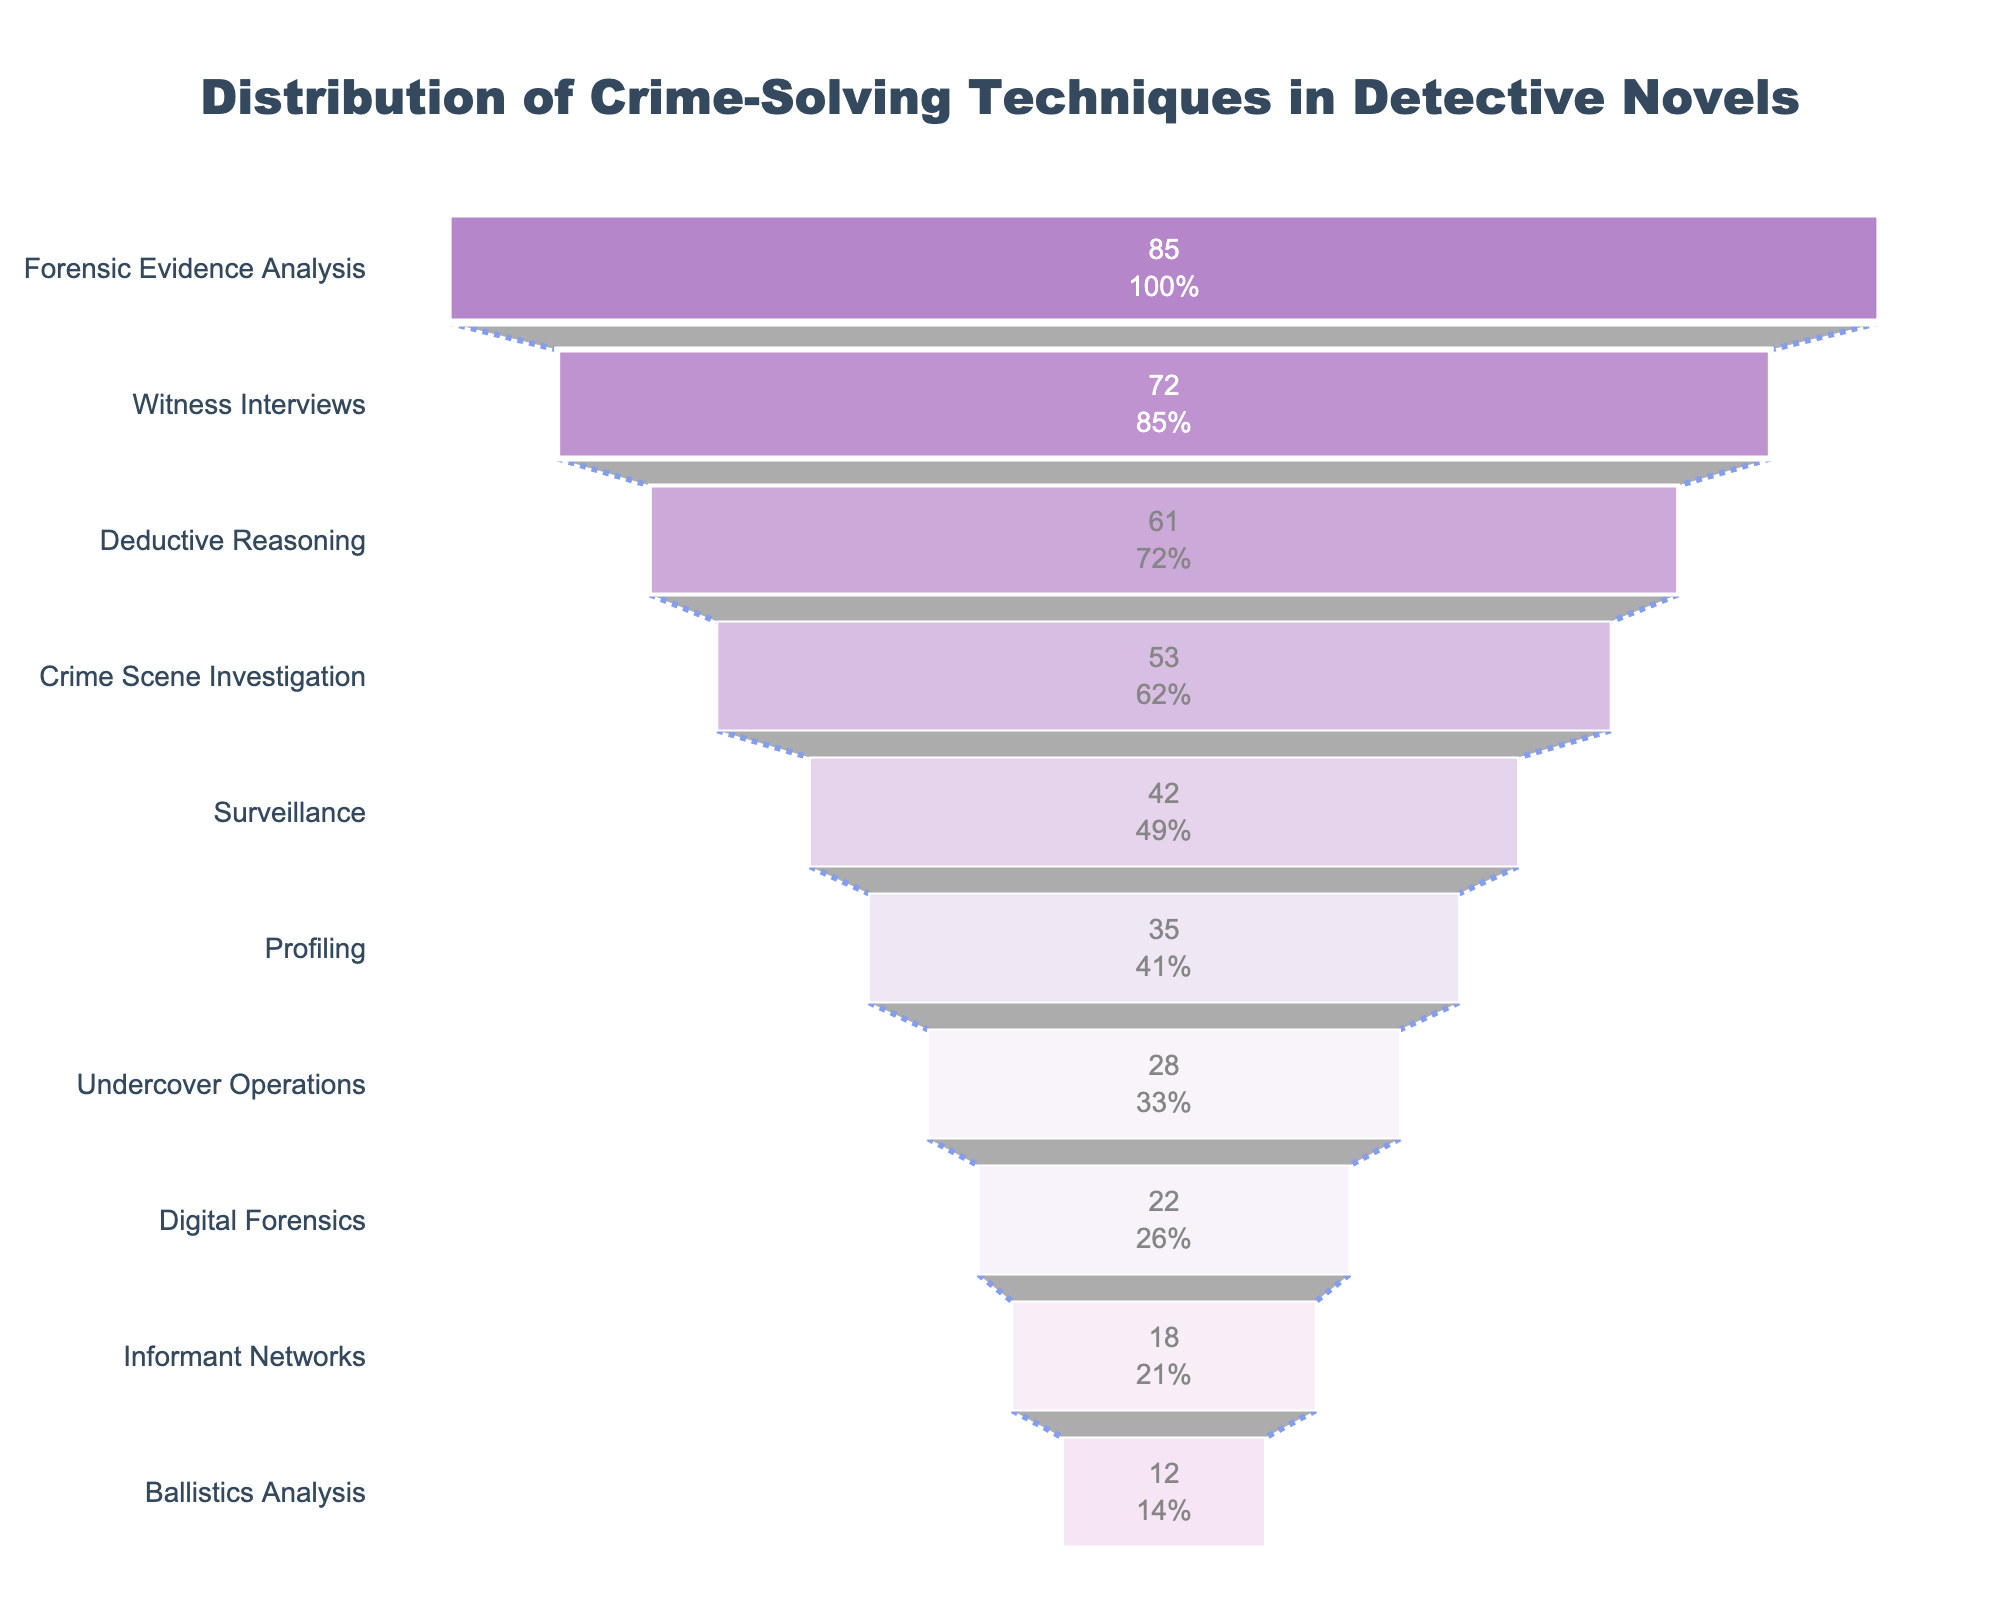What is the most frequently used crime-solving technique in detective novels? The top section of the funnel chart represents the technique with the highest frequency. It shows that Forensic Evidence Analysis has the highest frequency.
Answer: Forensic Evidence Analysis What percentage of the initial value does Witness Interviews contribute? The funnel chart shows percentage values for each technique next to their frequencies. Witness Interviews has a frequency of 72, and it is labeled as 84.7% of the initial value.
Answer: 84.7% Which technique has the lowest frequency, and what is its value? The bottom section of the funnel chart represents the technique with the lowest frequency. It shows that Ballistics Analysis has the lowest frequency, which is 12.
Answer: Ballistics Analysis, 12 How many techniques have a frequency greater than 50? By examining the bar lengths and values in the funnel chart, we observe that Forensic Evidence Analysis, Witness Interviews, Deductive Reasoning, and Crime Scene Investigation all have frequencies above 50.
Answer: Four techniques What is the combined frequency of Surveillance and Digital Forensics? Add the values for Surveillance (42) and Digital Forensics (22): 42 + 22 = 64.
Answer: 64 What is the difference in frequency between Witness Interviews and Profiling? Subtract the frequency of Profiling (35) from Witness Interviews (72): 72 - 35 = 37.
Answer: 37 Which techniques have a frequency close to the average frequency of all techniques? First, calculate the average frequency across all techniques: (85 + 72 + 61 + 53 + 42 + 35 + 28 + 22 + 18 + 12) / 10 = 42.8. Techniques with frequencies close to this are Surveillance (42) and Profiling (35).
Answer: Surveillance, Profiling Which technique shows the greatest percentage drop from the previous technique in the funnel? The percentage drop is greatest between Deductive Reasoning (61) and Crime Scene Investigation (53). Check the significant gaps in values and percentages between contiguous techniques; 8 is the highest drop.
Answer: Deductive Reasoning to Crime Scene Investigation What is the color distribution pattern in the funnel chart? Starting from the top, the colors vary gradually from dark purple (#8E44AD) to light purple (#F2D7EF). This gradient color scheme suggests visually distinguishing techniques by their frequency.
Answer: Gradient from dark to light purple 